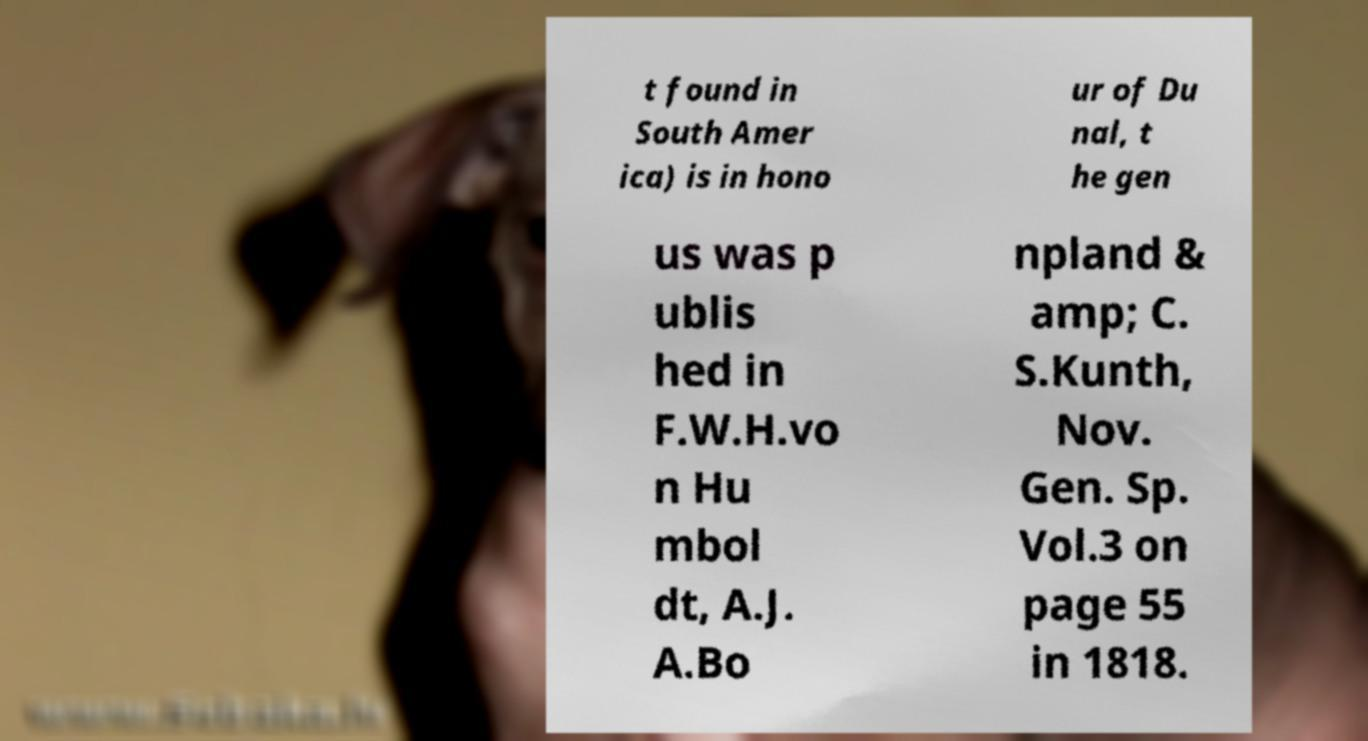Can you accurately transcribe the text from the provided image for me? t found in South Amer ica) is in hono ur of Du nal, t he gen us was p ublis hed in F.W.H.vo n Hu mbol dt, A.J. A.Bo npland & amp; C. S.Kunth, Nov. Gen. Sp. Vol.3 on page 55 in 1818. 